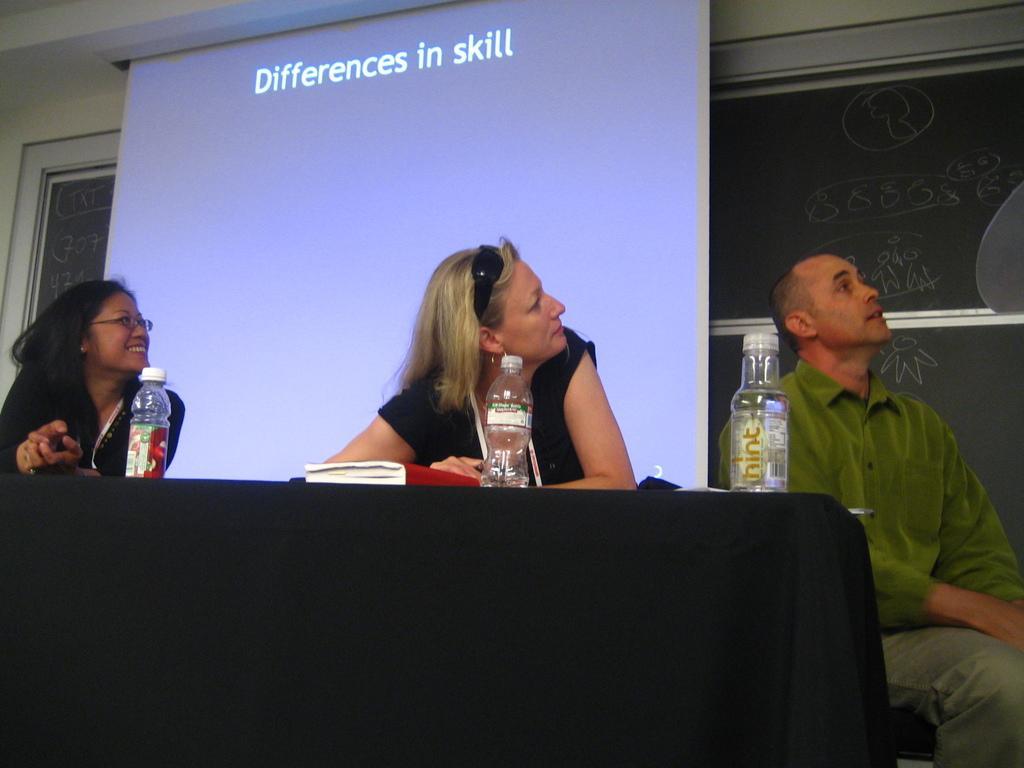In one or two sentences, can you explain what this image depicts? In this image I see 2 women and a man and I see that this woman is smiling and there is a table in front of them on which there are 3 bottles and I see a book over here. In the background I see the projector screen on which there are words written and I see the wall and a black board over here. 